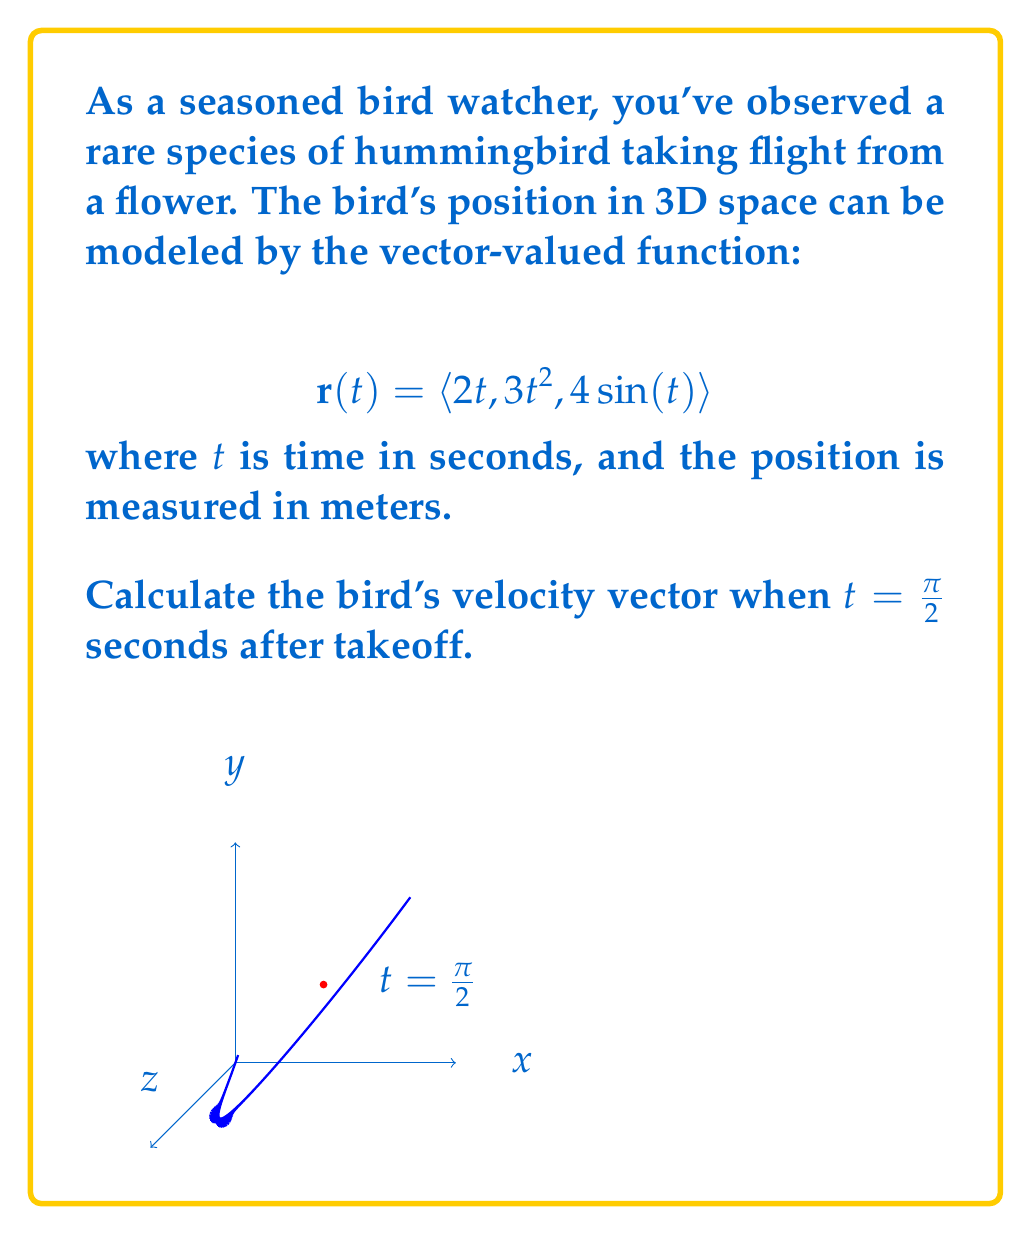Give your solution to this math problem. To solve this problem, we need to follow these steps:

1) The velocity vector is the derivative of the position vector with respect to time. We can find this by differentiating each component of $\mathbf{r}(t)$:

   $$\mathbf{v}(t) = \frac{d}{dt}\mathbf{r}(t) = \left\langle \frac{d}{dt}(2t), \frac{d}{dt}(3t^2), \frac{d}{dt}(4\sin(t)) \right\rangle$$

2) Let's differentiate each component:
   - $\frac{d}{dt}(2t) = 2$
   - $\frac{d}{dt}(3t^2) = 6t$
   - $\frac{d}{dt}(4\sin(t)) = 4\cos(t)$

3) Therefore, the velocity vector function is:

   $$\mathbf{v}(t) = \langle 2, 6t, 4\cos(t) \rangle$$

4) We need to evaluate this at $t = \frac{\pi}{2}$:

   $$\mathbf{v}(\frac{\pi}{2}) = \left\langle 2, 6(\frac{\pi}{2}), 4\cos(\frac{\pi}{2}) \right\rangle$$

5) Simplify:
   - $2$ remains as is
   - $6(\frac{\pi}{2}) = 3\pi$
   - $\cos(\frac{\pi}{2}) = 0$

6) Therefore, the final velocity vector is:

   $$\mathbf{v}(\frac{\pi}{2}) = \langle 2, 3\pi, 0 \rangle$$

This vector represents the bird's instantaneous velocity $\frac{\pi}{2}$ seconds after takeoff, measured in meters per second.
Answer: $\langle 2, 3\pi, 0 \rangle$ m/s 